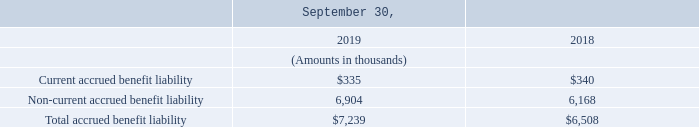Plans with projected benefit obligations in excess of plan assets are attributable to unfunded domestic supplemental retirement plans, and our U.K. retirement plan.
Accrued benefit liability reported as:
As of September 30, 2019 and 2018, the amounts included in accumulated other comprehensive income, consisted of
deferred net losses totaling approximately $6.3 million and $5.3 million, respectively.
The amount of net deferred loss expected to be recognized as a component of net periodic benefit cost for the year ending September 30, 2019, is approximately $229 thousand.
What is the amount of net deferred loss expected to be recognized as a component of net periodic benefit cost for the year ending September 30, 2019? $229 thousand. What is the amount included in accumulated other comprehensive income as of September 30, 2019? $6.3 million. What is the amount included in accumulated other comprehensive income as of September 30, 2018? $5.3 million. What is the percentage change in the current accrued benefit liability between 2018 and 2019?
Answer scale should be: percent. (335 - 340)/340 
Answer: -1.47. What is the change in non-current accrued benefit liability between 2018 and 2019?
Answer scale should be: thousand. 6,904 - 6,168 
Answer: 736. How much is the current accrued benefit liability as a percentage of the total accrued benefit liability in 2019?
Answer scale should be: percent. 335/7,239 
Answer: 4.63. 